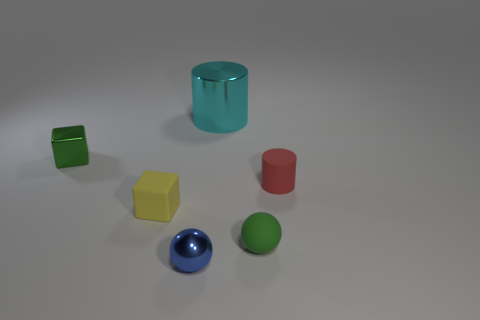Add 4 large cyan rubber balls. How many objects exist? 10 Subtract all spheres. How many objects are left? 4 Add 1 metal cubes. How many metal cubes are left? 2 Add 4 small matte cylinders. How many small matte cylinders exist? 5 Subtract 1 yellow cubes. How many objects are left? 5 Subtract all blue metal objects. Subtract all tiny green rubber objects. How many objects are left? 4 